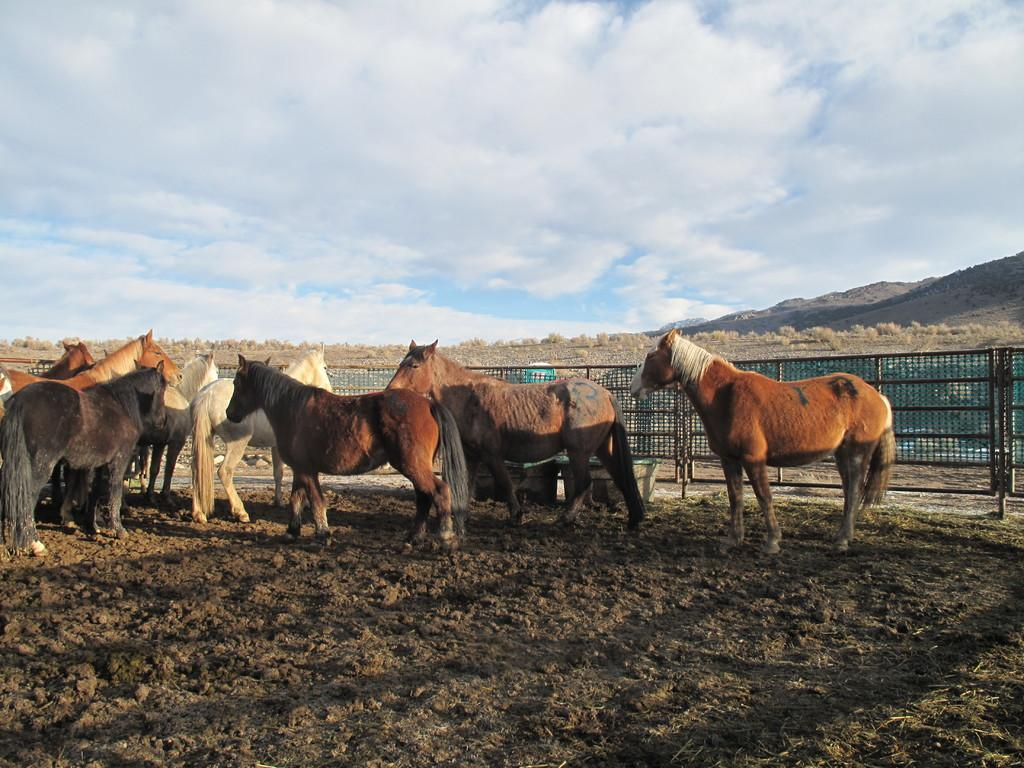What animals can be seen on the surface in the image? There are horses on the surface in the image. What type of vegetation is visible in the image? There is grass visible in the image. What objects can be seen in the image? There are tubs in the image. What type of barrier is present in the image? There is a fence in the image. What can be seen in the background of the image? There is grass, hills, and the sky visible in the background of the image. What is present in the sky in the image? Clouds are present in the sky in the image. What is the profit made by the horses in the image? There is no mention of profit or any financial aspect related to the horses in the image. 